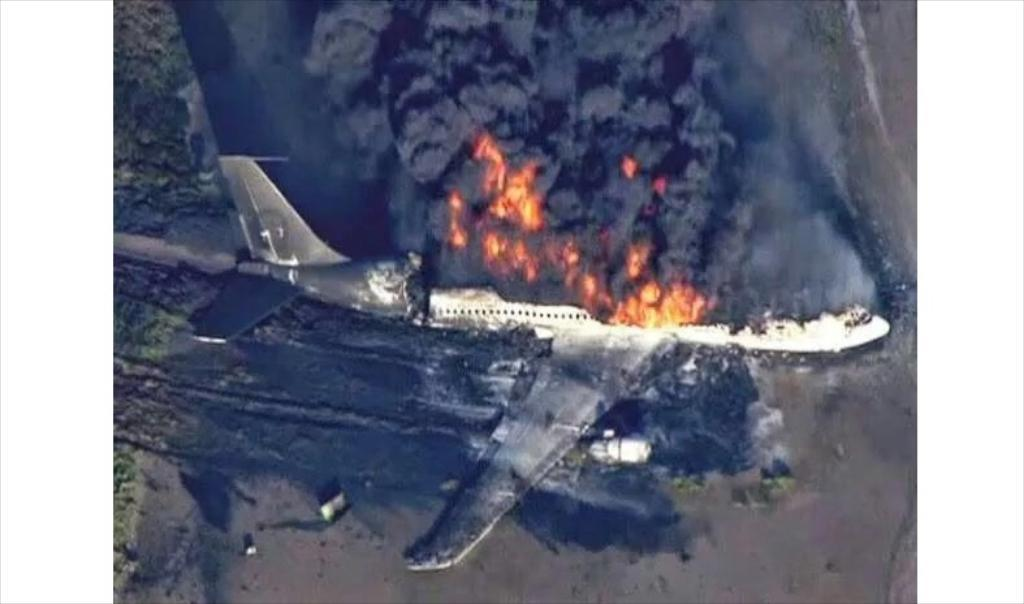What is the main subject of the image? The main subject of the image is a plane. Where is the plane located in the image? The plane is on the ground in the image. What is happening to the plane? The plane is burning in the image. What can be seen as a result of the burning plane? There is fire and smoke visible in the image. What type of potato is being used to extinguish the fire in the image? There is no potato present in the image, and therefore no such action can be observed. What role does the leaf play in the image? There is no leaf present in the image, so it cannot play any role. 